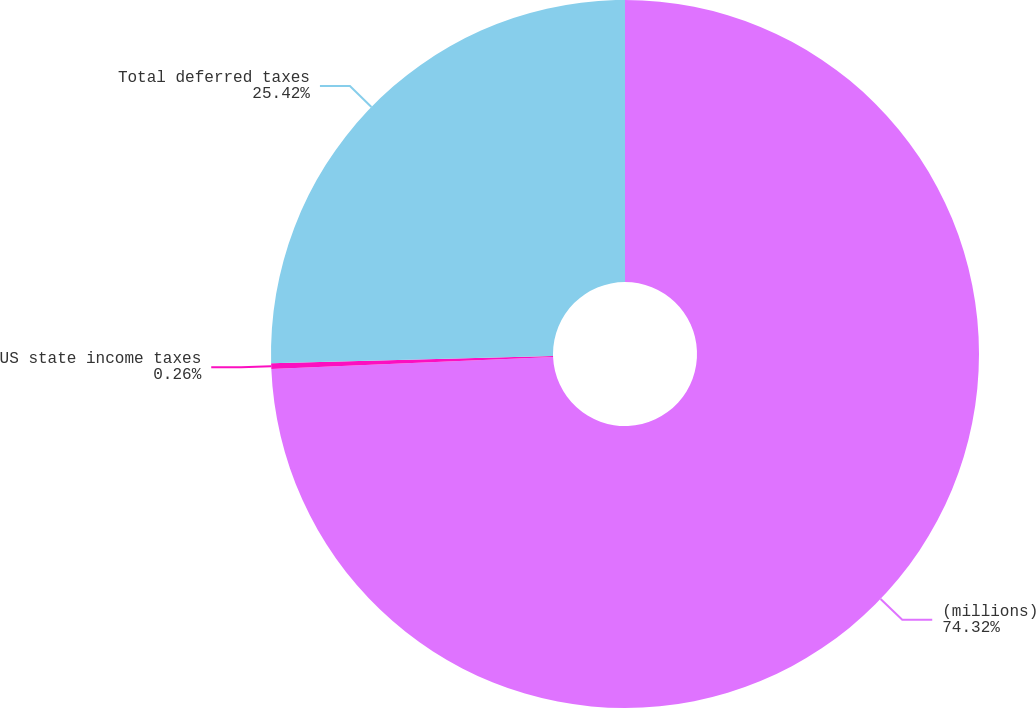<chart> <loc_0><loc_0><loc_500><loc_500><pie_chart><fcel>(millions)<fcel>US state income taxes<fcel>Total deferred taxes<nl><fcel>74.33%<fcel>0.26%<fcel>25.42%<nl></chart> 